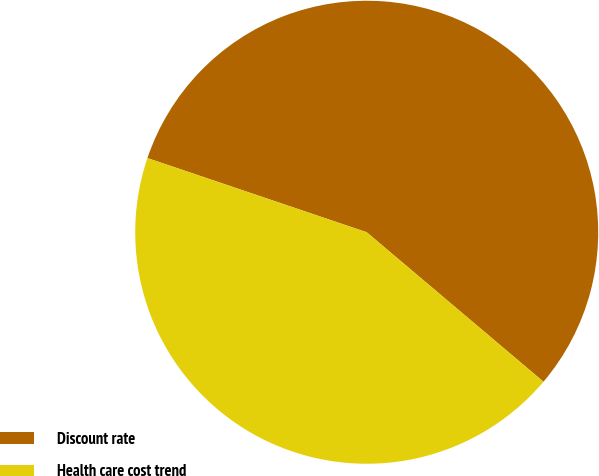Convert chart to OTSL. <chart><loc_0><loc_0><loc_500><loc_500><pie_chart><fcel>Discount rate<fcel>Health care cost trend<nl><fcel>55.98%<fcel>44.02%<nl></chart> 